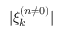Convert formula to latex. <formula><loc_0><loc_0><loc_500><loc_500>| \xi _ { k } ^ { ( n \neq 0 ) } |</formula> 